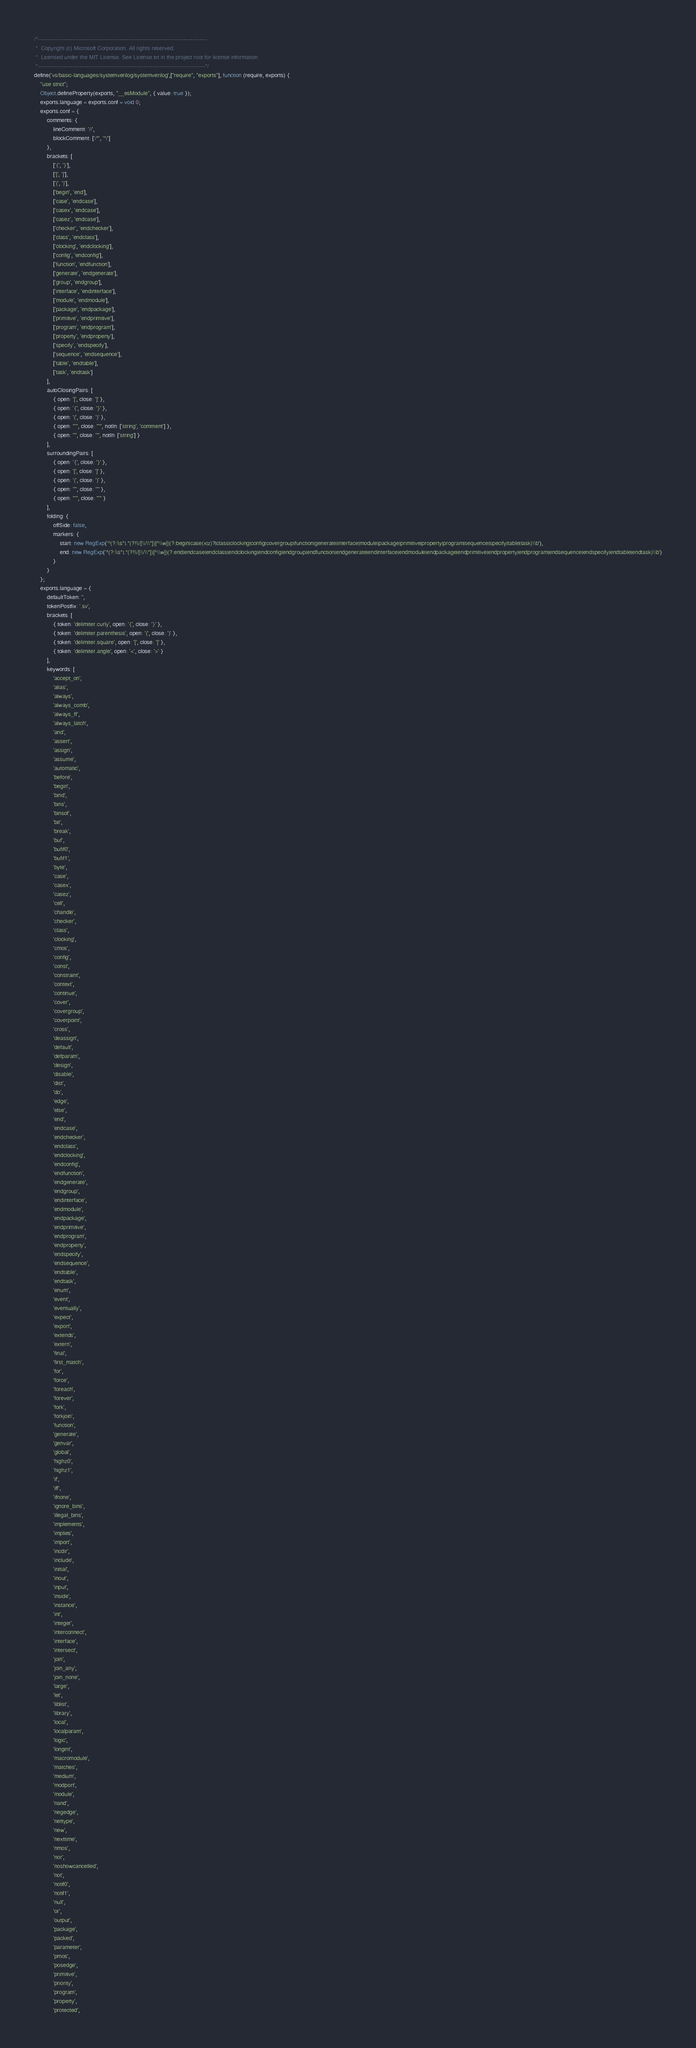Convert code to text. <code><loc_0><loc_0><loc_500><loc_500><_JavaScript_>/*---------------------------------------------------------------------------------------------
 *  Copyright (c) Microsoft Corporation. All rights reserved.
 *  Licensed under the MIT License. See License.txt in the project root for license information.
 *--------------------------------------------------------------------------------------------*/
define('vs/basic-languages/systemverilog/systemverilog',["require", "exports"], function (require, exports) {
    "use strict";
    Object.defineProperty(exports, "__esModule", { value: true });
    exports.language = exports.conf = void 0;
    exports.conf = {
        comments: {
            lineComment: '//',
            blockComment: ['/*', '*/']
        },
        brackets: [
            ['{', '}'],
            ['[', ']'],
            ['(', ')'],
            ['begin', 'end'],
            ['case', 'endcase'],
            ['casex', 'endcase'],
            ['casez', 'endcase'],
            ['checker', 'endchecker'],
            ['class', 'endclass'],
            ['clocking', 'endclocking'],
            ['config', 'endconfig'],
            ['function', 'endfunction'],
            ['generate', 'endgenerate'],
            ['group', 'endgroup'],
            ['interface', 'endinterface'],
            ['module', 'endmodule'],
            ['package', 'endpackage'],
            ['primitive', 'endprimitive'],
            ['program', 'endprogram'],
            ['property', 'endproperty'],
            ['specify', 'endspecify'],
            ['sequence', 'endsequence'],
            ['table', 'endtable'],
            ['task', 'endtask']
        ],
        autoClosingPairs: [
            { open: '[', close: ']' },
            { open: '{', close: '}' },
            { open: '(', close: ')' },
            { open: "'", close: "'", notIn: ['string', 'comment'] },
            { open: '"', close: '"', notIn: ['string'] }
        ],
        surroundingPairs: [
            { open: '{', close: '}' },
            { open: '[', close: ']' },
            { open: '(', close: ')' },
            { open: '"', close: '"' },
            { open: "'", close: "'" }
        ],
        folding: {
            offSide: false,
            markers: {
                start: new RegExp('^(?:\\s*|.*(?!\\/[\\/\\*])[^\\w])(?:begin|case(x|z)?|class|clocking|config|covergroup|function|generate|interface|module|package|primitive|property|program|sequence|specify|table|task)\\b'),
                end: new RegExp('^(?:\\s*|.*(?!\\/[\\/\\*])[^\\w])(?:end|endcase|endclass|endclocking|endconfig|endgroup|endfunction|endgenerate|endinterface|endmodule|endpackage|endprimitive|endproperty|endprogram|endsequence|endspecify|endtable|endtask)\\b')
            }
        }
    };
    exports.language = {
        defaultToken: '',
        tokenPostfix: '.sv',
        brackets: [
            { token: 'delimiter.curly', open: '{', close: '}' },
            { token: 'delimiter.parenthesis', open: '(', close: ')' },
            { token: 'delimiter.square', open: '[', close: ']' },
            { token: 'delimiter.angle', open: '<', close: '>' }
        ],
        keywords: [
            'accept_on',
            'alias',
            'always',
            'always_comb',
            'always_ff',
            'always_latch',
            'and',
            'assert',
            'assign',
            'assume',
            'automatic',
            'before',
            'begin',
            'bind',
            'bins',
            'binsof',
            'bit',
            'break',
            'buf',
            'bufif0',
            'bufif1',
            'byte',
            'case',
            'casex',
            'casez',
            'cell',
            'chandle',
            'checker',
            'class',
            'clocking',
            'cmos',
            'config',
            'const',
            'constraint',
            'context',
            'continue',
            'cover',
            'covergroup',
            'coverpoint',
            'cross',
            'deassign',
            'default',
            'defparam',
            'design',
            'disable',
            'dist',
            'do',
            'edge',
            'else',
            'end',
            'endcase',
            'endchecker',
            'endclass',
            'endclocking',
            'endconfig',
            'endfunction',
            'endgenerate',
            'endgroup',
            'endinterface',
            'endmodule',
            'endpackage',
            'endprimitive',
            'endprogram',
            'endproperty',
            'endspecify',
            'endsequence',
            'endtable',
            'endtask',
            'enum',
            'event',
            'eventually',
            'expect',
            'export',
            'extends',
            'extern',
            'final',
            'first_match',
            'for',
            'force',
            'foreach',
            'forever',
            'fork',
            'forkjoin',
            'function',
            'generate',
            'genvar',
            'global',
            'highz0',
            'highz1',
            'if',
            'iff',
            'ifnone',
            'ignore_bins',
            'illegal_bins',
            'implements',
            'implies',
            'import',
            'incdir',
            'include',
            'initial',
            'inout',
            'input',
            'inside',
            'instance',
            'int',
            'integer',
            'interconnect',
            'interface',
            'intersect',
            'join',
            'join_any',
            'join_none',
            'large',
            'let',
            'liblist',
            'library',
            'local',
            'localparam',
            'logic',
            'longint',
            'macromodule',
            'matches',
            'medium',
            'modport',
            'module',
            'nand',
            'negedge',
            'nettype',
            'new',
            'nexttime',
            'nmos',
            'nor',
            'noshowcancelled',
            'not',
            'notif0',
            'notif1',
            'null',
            'or',
            'output',
            'package',
            'packed',
            'parameter',
            'pmos',
            'posedge',
            'primitive',
            'priority',
            'program',
            'property',
            'protected',</code> 